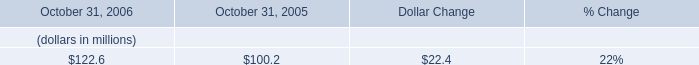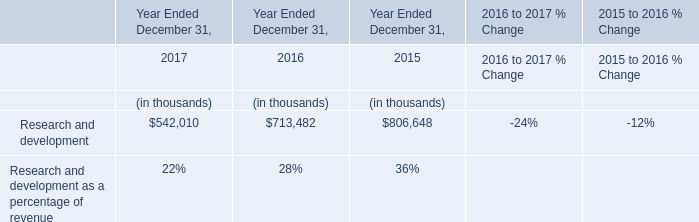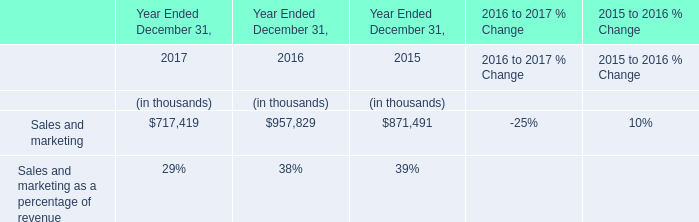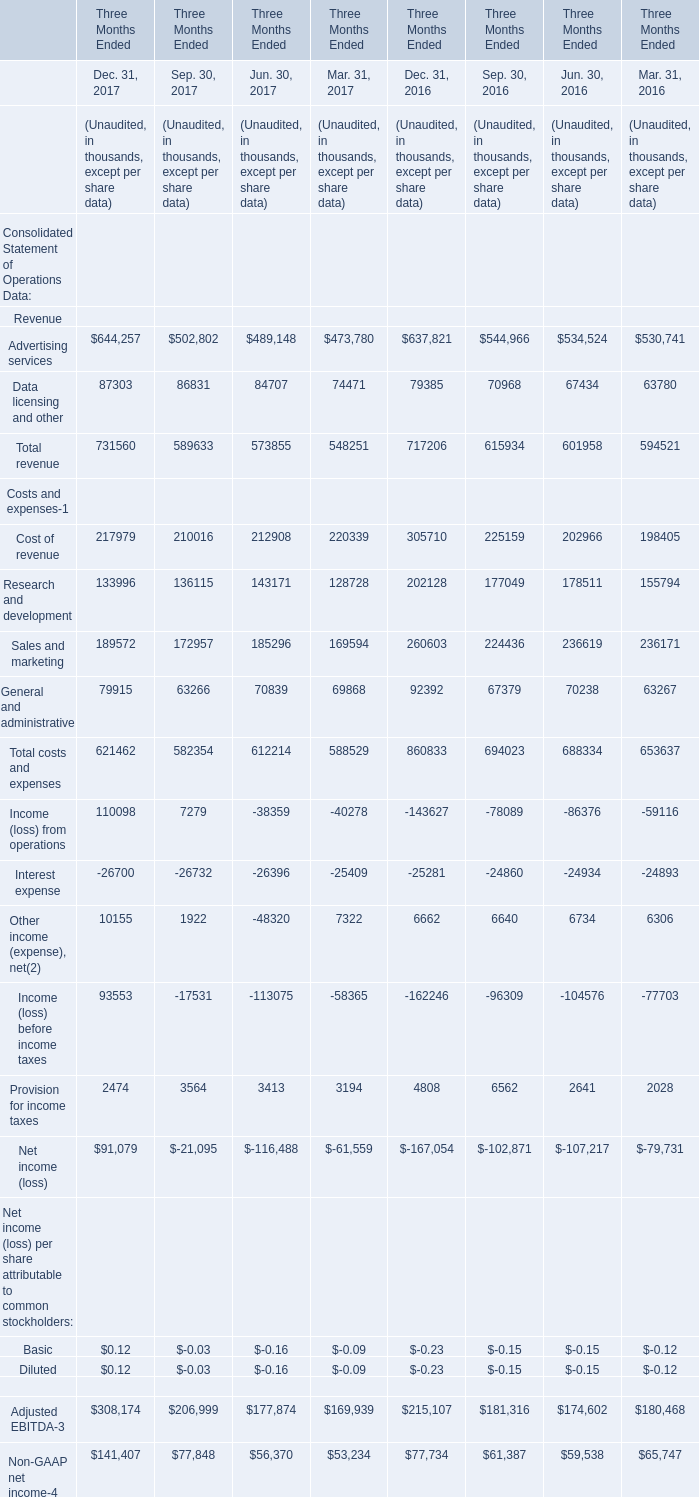As As the chart 3 shows,which year is Total costs and expenses for Three Months Ended Jun. 30 the lowest? 
Answer: 2017. 